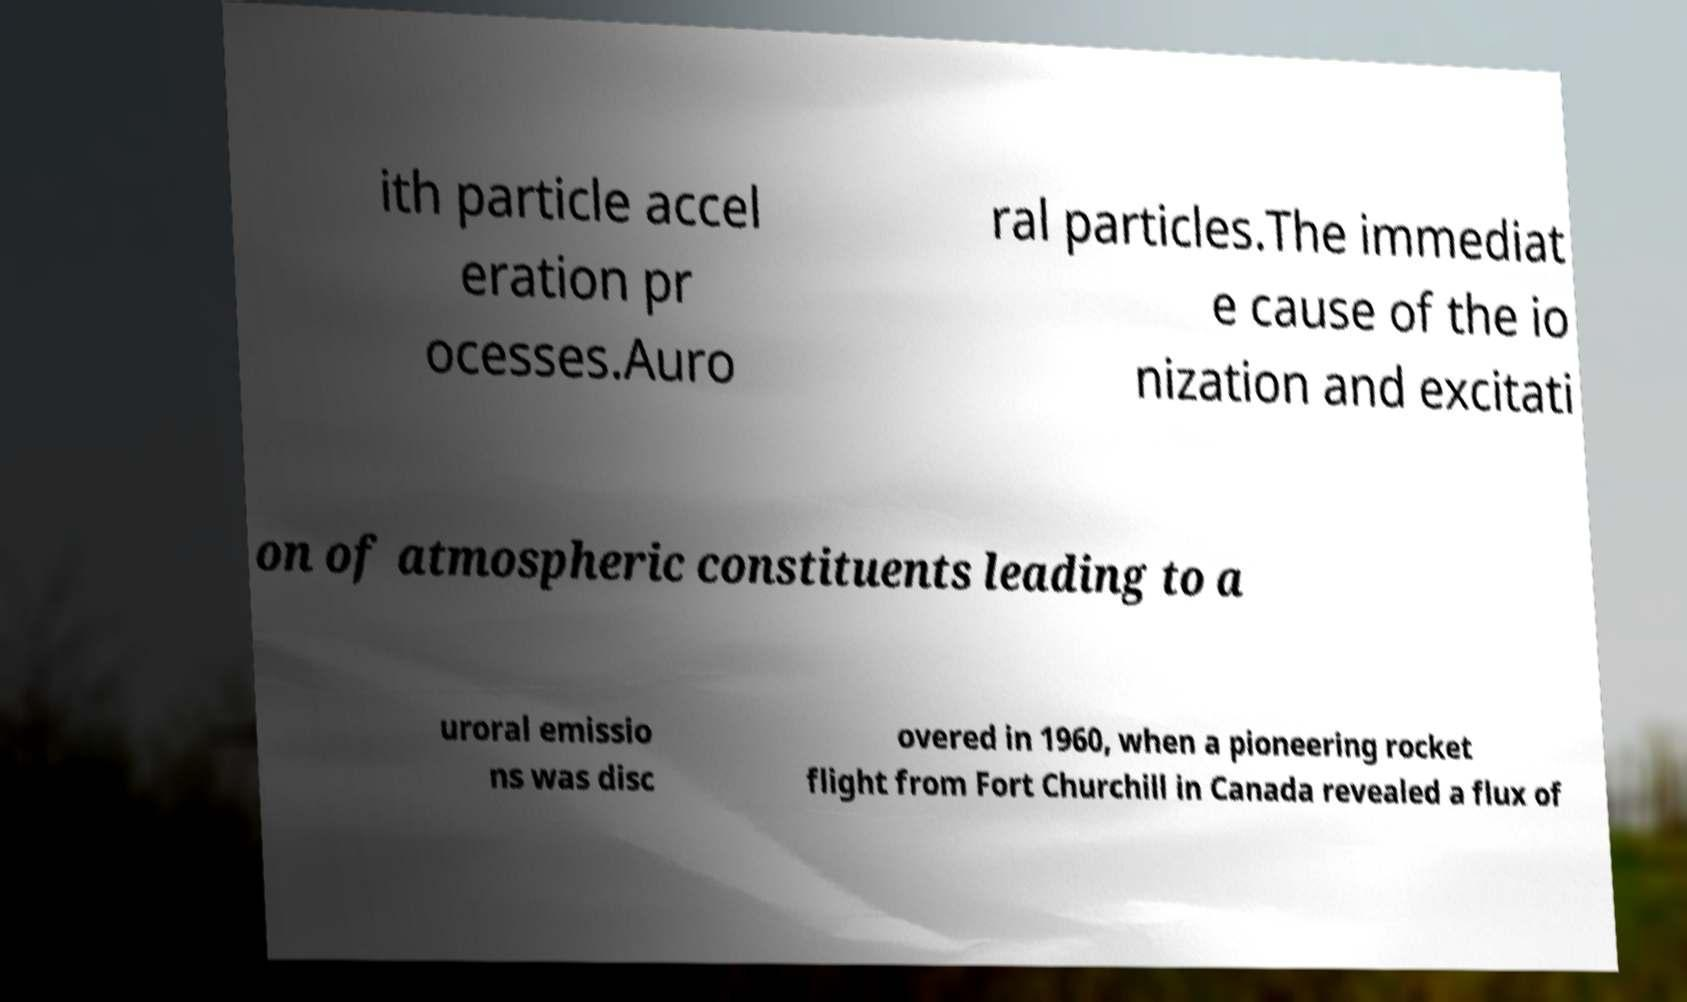There's text embedded in this image that I need extracted. Can you transcribe it verbatim? ith particle accel eration pr ocesses.Auro ral particles.The immediat e cause of the io nization and excitati on of atmospheric constituents leading to a uroral emissio ns was disc overed in 1960, when a pioneering rocket flight from Fort Churchill in Canada revealed a flux of 